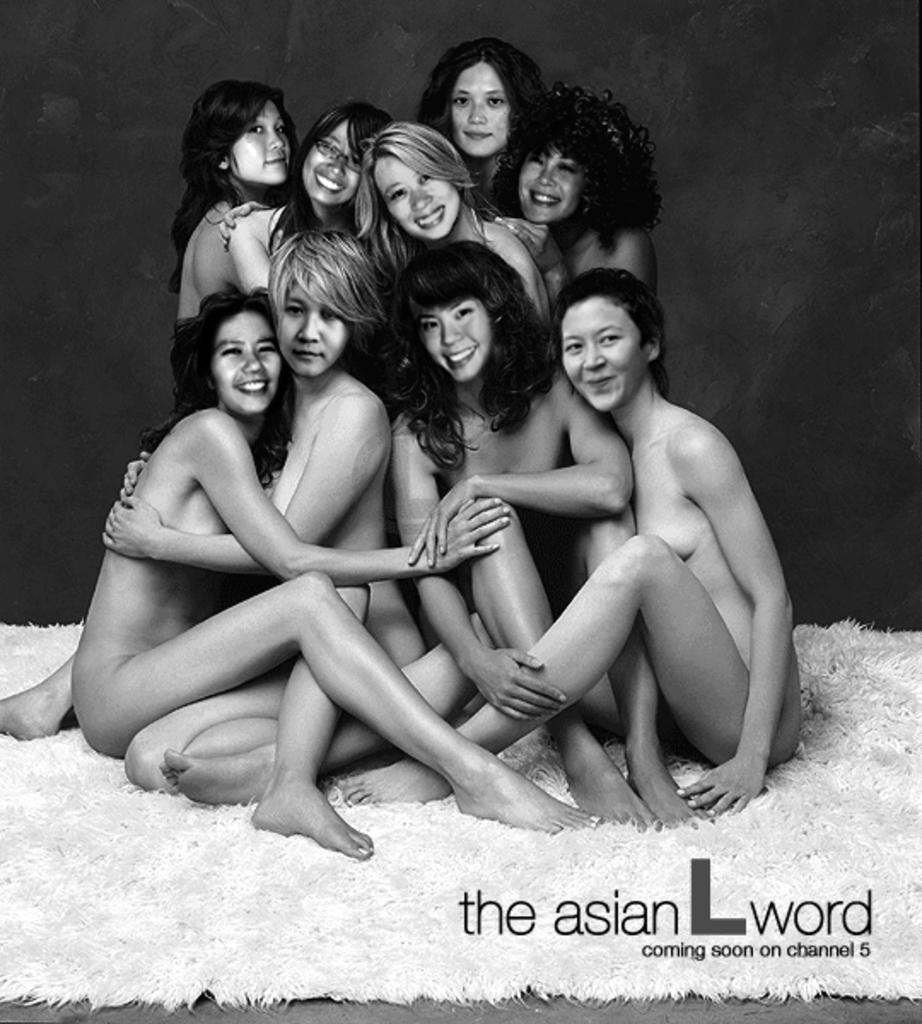What is the color scheme of the image? The image is black and white. Who is present in the image? There is a group of women in the image. What are the women doing in the image? The women are sitting on a surface. Is there any text present in the image? Yes, there is text on the image. What type of calculator can be seen in the image? There is no calculator present in the image. What kind of vessel is being used by the women in the image? There is no vessel visible in the image; the women are sitting on a surface. 